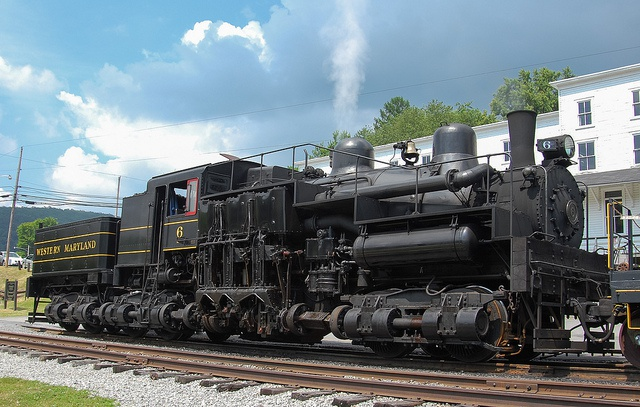Describe the objects in this image and their specific colors. I can see train in lightblue, black, gray, darkgray, and lightgray tones and car in lightblue, lightgray, darkgray, and gray tones in this image. 